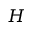Convert formula to latex. <formula><loc_0><loc_0><loc_500><loc_500>H</formula> 